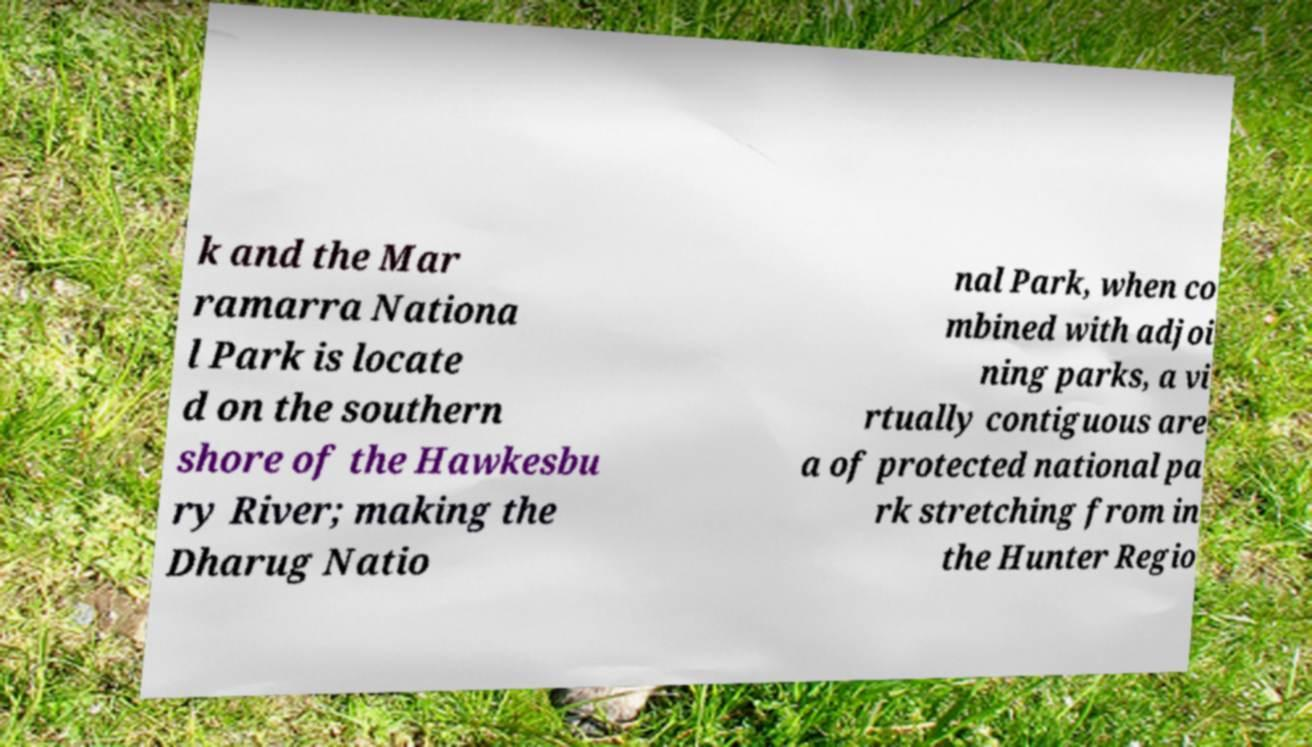Can you accurately transcribe the text from the provided image for me? k and the Mar ramarra Nationa l Park is locate d on the southern shore of the Hawkesbu ry River; making the Dharug Natio nal Park, when co mbined with adjoi ning parks, a vi rtually contiguous are a of protected national pa rk stretching from in the Hunter Regio 